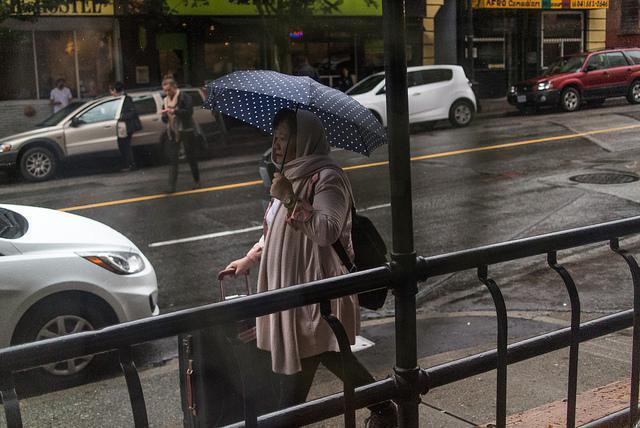Why is the woman carrying luggage?
Make your selection and explain in format: 'Answer: answer
Rationale: rationale.'
Options: To travel, to buy, to sell, to trade. Answer: to travel.
Rationale: People use luggage to carry their belongings when they travel. 